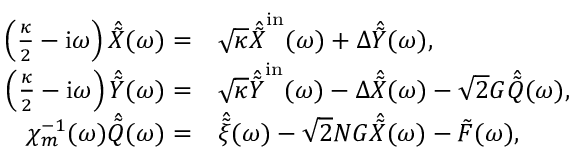<formula> <loc_0><loc_0><loc_500><loc_500>\begin{array} { r l } { \left ( \frac { \kappa } { 2 } - i \omega \right ) \hat { \tilde { X } } ( \omega ) = } & { \sqrt { \kappa } \hat { \tilde { X } } ^ { i n } ( \omega ) + \Delta \hat { \tilde { Y } } ( \omega ) , } \\ { \left ( \frac { \kappa } { 2 } - i \omega \right ) \hat { \tilde { Y } } ( \omega ) = } & { \sqrt { \kappa } \hat { \tilde { Y } } ^ { i n } ( \omega ) - \Delta \hat { \tilde { X } } ( \omega ) - \sqrt { 2 } G \hat { \tilde { Q } } ( \omega ) , } \\ { \chi _ { m } ^ { - 1 } ( \omega ) \hat { \tilde { Q } } ( \omega ) = } & { \hat { \tilde { \xi } } ( \omega ) - \sqrt { 2 } N G \hat { \tilde { X } } ( \omega ) - \tilde { F } ( \omega ) , } \end{array}</formula> 